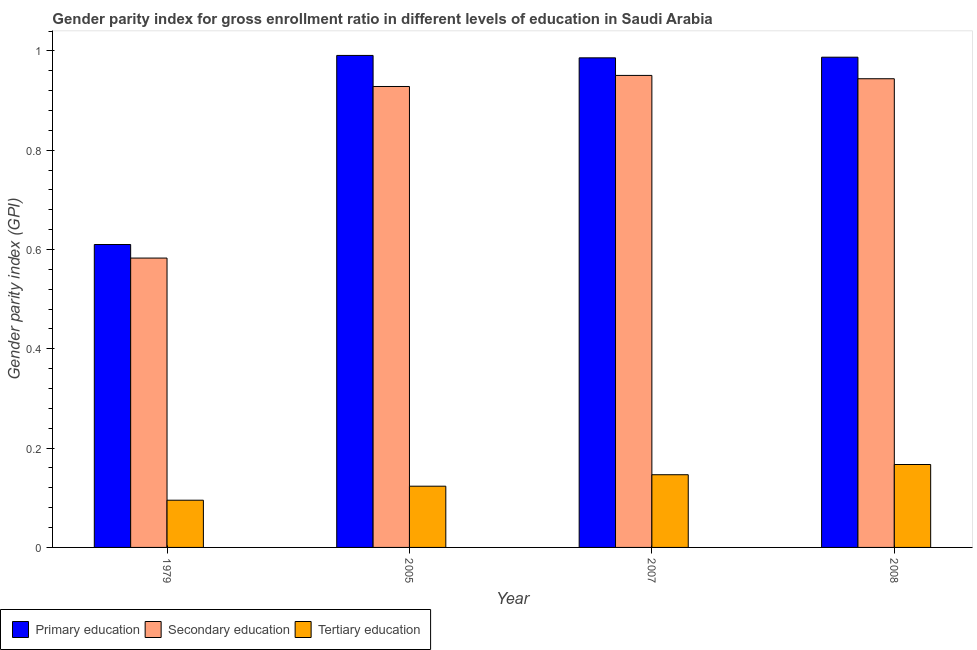How many groups of bars are there?
Ensure brevity in your answer.  4. Are the number of bars per tick equal to the number of legend labels?
Offer a terse response. Yes. Are the number of bars on each tick of the X-axis equal?
Your answer should be compact. Yes. How many bars are there on the 1st tick from the right?
Your response must be concise. 3. What is the label of the 4th group of bars from the left?
Ensure brevity in your answer.  2008. What is the gender parity index in primary education in 2005?
Ensure brevity in your answer.  0.99. Across all years, what is the maximum gender parity index in primary education?
Offer a terse response. 0.99. Across all years, what is the minimum gender parity index in secondary education?
Your response must be concise. 0.58. In which year was the gender parity index in primary education maximum?
Provide a short and direct response. 2005. In which year was the gender parity index in tertiary education minimum?
Your response must be concise. 1979. What is the total gender parity index in secondary education in the graph?
Offer a very short reply. 3.41. What is the difference between the gender parity index in primary education in 2007 and that in 2008?
Your answer should be compact. -0. What is the difference between the gender parity index in primary education in 2008 and the gender parity index in tertiary education in 2005?
Keep it short and to the point. -0. What is the average gender parity index in secondary education per year?
Keep it short and to the point. 0.85. In the year 2005, what is the difference between the gender parity index in secondary education and gender parity index in tertiary education?
Your answer should be compact. 0. What is the ratio of the gender parity index in secondary education in 1979 to that in 2008?
Provide a succinct answer. 0.62. Is the difference between the gender parity index in secondary education in 2005 and 2007 greater than the difference between the gender parity index in tertiary education in 2005 and 2007?
Make the answer very short. No. What is the difference between the highest and the second highest gender parity index in primary education?
Your response must be concise. 0. What is the difference between the highest and the lowest gender parity index in secondary education?
Provide a succinct answer. 0.37. In how many years, is the gender parity index in secondary education greater than the average gender parity index in secondary education taken over all years?
Give a very brief answer. 3. What does the 3rd bar from the left in 2007 represents?
Give a very brief answer. Tertiary education. What does the 1st bar from the right in 1979 represents?
Your answer should be compact. Tertiary education. Is it the case that in every year, the sum of the gender parity index in primary education and gender parity index in secondary education is greater than the gender parity index in tertiary education?
Your response must be concise. Yes. How many years are there in the graph?
Keep it short and to the point. 4. Are the values on the major ticks of Y-axis written in scientific E-notation?
Keep it short and to the point. No. Does the graph contain grids?
Your answer should be very brief. No. What is the title of the graph?
Your response must be concise. Gender parity index for gross enrollment ratio in different levels of education in Saudi Arabia. Does "ICT services" appear as one of the legend labels in the graph?
Give a very brief answer. No. What is the label or title of the X-axis?
Provide a short and direct response. Year. What is the label or title of the Y-axis?
Provide a short and direct response. Gender parity index (GPI). What is the Gender parity index (GPI) in Primary education in 1979?
Make the answer very short. 0.61. What is the Gender parity index (GPI) in Secondary education in 1979?
Provide a short and direct response. 0.58. What is the Gender parity index (GPI) in Tertiary education in 1979?
Provide a succinct answer. 0.1. What is the Gender parity index (GPI) of Primary education in 2005?
Make the answer very short. 0.99. What is the Gender parity index (GPI) of Secondary education in 2005?
Your answer should be compact. 0.93. What is the Gender parity index (GPI) of Tertiary education in 2005?
Keep it short and to the point. 0.12. What is the Gender parity index (GPI) of Primary education in 2007?
Give a very brief answer. 0.99. What is the Gender parity index (GPI) of Secondary education in 2007?
Your answer should be compact. 0.95. What is the Gender parity index (GPI) of Tertiary education in 2007?
Provide a short and direct response. 0.15. What is the Gender parity index (GPI) of Primary education in 2008?
Your answer should be very brief. 0.99. What is the Gender parity index (GPI) in Secondary education in 2008?
Your answer should be compact. 0.94. What is the Gender parity index (GPI) of Tertiary education in 2008?
Your answer should be very brief. 0.17. Across all years, what is the maximum Gender parity index (GPI) of Primary education?
Give a very brief answer. 0.99. Across all years, what is the maximum Gender parity index (GPI) in Secondary education?
Provide a succinct answer. 0.95. Across all years, what is the maximum Gender parity index (GPI) of Tertiary education?
Offer a very short reply. 0.17. Across all years, what is the minimum Gender parity index (GPI) of Primary education?
Your response must be concise. 0.61. Across all years, what is the minimum Gender parity index (GPI) of Secondary education?
Ensure brevity in your answer.  0.58. Across all years, what is the minimum Gender parity index (GPI) in Tertiary education?
Your answer should be very brief. 0.1. What is the total Gender parity index (GPI) in Primary education in the graph?
Your answer should be very brief. 3.57. What is the total Gender parity index (GPI) of Secondary education in the graph?
Ensure brevity in your answer.  3.41. What is the total Gender parity index (GPI) of Tertiary education in the graph?
Provide a succinct answer. 0.53. What is the difference between the Gender parity index (GPI) of Primary education in 1979 and that in 2005?
Offer a terse response. -0.38. What is the difference between the Gender parity index (GPI) of Secondary education in 1979 and that in 2005?
Keep it short and to the point. -0.35. What is the difference between the Gender parity index (GPI) in Tertiary education in 1979 and that in 2005?
Provide a succinct answer. -0.03. What is the difference between the Gender parity index (GPI) of Primary education in 1979 and that in 2007?
Your response must be concise. -0.38. What is the difference between the Gender parity index (GPI) of Secondary education in 1979 and that in 2007?
Your answer should be compact. -0.37. What is the difference between the Gender parity index (GPI) of Tertiary education in 1979 and that in 2007?
Offer a very short reply. -0.05. What is the difference between the Gender parity index (GPI) in Primary education in 1979 and that in 2008?
Your answer should be compact. -0.38. What is the difference between the Gender parity index (GPI) of Secondary education in 1979 and that in 2008?
Give a very brief answer. -0.36. What is the difference between the Gender parity index (GPI) of Tertiary education in 1979 and that in 2008?
Ensure brevity in your answer.  -0.07. What is the difference between the Gender parity index (GPI) in Primary education in 2005 and that in 2007?
Give a very brief answer. 0. What is the difference between the Gender parity index (GPI) in Secondary education in 2005 and that in 2007?
Keep it short and to the point. -0.02. What is the difference between the Gender parity index (GPI) in Tertiary education in 2005 and that in 2007?
Keep it short and to the point. -0.02. What is the difference between the Gender parity index (GPI) in Primary education in 2005 and that in 2008?
Keep it short and to the point. 0. What is the difference between the Gender parity index (GPI) in Secondary education in 2005 and that in 2008?
Offer a terse response. -0.02. What is the difference between the Gender parity index (GPI) in Tertiary education in 2005 and that in 2008?
Keep it short and to the point. -0.04. What is the difference between the Gender parity index (GPI) of Primary education in 2007 and that in 2008?
Provide a short and direct response. -0. What is the difference between the Gender parity index (GPI) of Secondary education in 2007 and that in 2008?
Offer a terse response. 0.01. What is the difference between the Gender parity index (GPI) in Tertiary education in 2007 and that in 2008?
Your response must be concise. -0.02. What is the difference between the Gender parity index (GPI) of Primary education in 1979 and the Gender parity index (GPI) of Secondary education in 2005?
Your response must be concise. -0.32. What is the difference between the Gender parity index (GPI) of Primary education in 1979 and the Gender parity index (GPI) of Tertiary education in 2005?
Keep it short and to the point. 0.49. What is the difference between the Gender parity index (GPI) in Secondary education in 1979 and the Gender parity index (GPI) in Tertiary education in 2005?
Offer a very short reply. 0.46. What is the difference between the Gender parity index (GPI) of Primary education in 1979 and the Gender parity index (GPI) of Secondary education in 2007?
Your answer should be very brief. -0.34. What is the difference between the Gender parity index (GPI) of Primary education in 1979 and the Gender parity index (GPI) of Tertiary education in 2007?
Offer a terse response. 0.46. What is the difference between the Gender parity index (GPI) in Secondary education in 1979 and the Gender parity index (GPI) in Tertiary education in 2007?
Keep it short and to the point. 0.44. What is the difference between the Gender parity index (GPI) in Primary education in 1979 and the Gender parity index (GPI) in Secondary education in 2008?
Provide a succinct answer. -0.33. What is the difference between the Gender parity index (GPI) in Primary education in 1979 and the Gender parity index (GPI) in Tertiary education in 2008?
Provide a succinct answer. 0.44. What is the difference between the Gender parity index (GPI) of Secondary education in 1979 and the Gender parity index (GPI) of Tertiary education in 2008?
Provide a short and direct response. 0.42. What is the difference between the Gender parity index (GPI) of Primary education in 2005 and the Gender parity index (GPI) of Secondary education in 2007?
Ensure brevity in your answer.  0.04. What is the difference between the Gender parity index (GPI) of Primary education in 2005 and the Gender parity index (GPI) of Tertiary education in 2007?
Offer a very short reply. 0.84. What is the difference between the Gender parity index (GPI) of Secondary education in 2005 and the Gender parity index (GPI) of Tertiary education in 2007?
Your answer should be very brief. 0.78. What is the difference between the Gender parity index (GPI) of Primary education in 2005 and the Gender parity index (GPI) of Secondary education in 2008?
Your answer should be very brief. 0.05. What is the difference between the Gender parity index (GPI) in Primary education in 2005 and the Gender parity index (GPI) in Tertiary education in 2008?
Make the answer very short. 0.82. What is the difference between the Gender parity index (GPI) of Secondary education in 2005 and the Gender parity index (GPI) of Tertiary education in 2008?
Your answer should be compact. 0.76. What is the difference between the Gender parity index (GPI) of Primary education in 2007 and the Gender parity index (GPI) of Secondary education in 2008?
Provide a succinct answer. 0.04. What is the difference between the Gender parity index (GPI) of Primary education in 2007 and the Gender parity index (GPI) of Tertiary education in 2008?
Your answer should be compact. 0.82. What is the difference between the Gender parity index (GPI) in Secondary education in 2007 and the Gender parity index (GPI) in Tertiary education in 2008?
Offer a terse response. 0.78. What is the average Gender parity index (GPI) of Primary education per year?
Give a very brief answer. 0.89. What is the average Gender parity index (GPI) in Secondary education per year?
Your answer should be very brief. 0.85. What is the average Gender parity index (GPI) in Tertiary education per year?
Make the answer very short. 0.13. In the year 1979, what is the difference between the Gender parity index (GPI) in Primary education and Gender parity index (GPI) in Secondary education?
Give a very brief answer. 0.03. In the year 1979, what is the difference between the Gender parity index (GPI) in Primary education and Gender parity index (GPI) in Tertiary education?
Offer a terse response. 0.52. In the year 1979, what is the difference between the Gender parity index (GPI) in Secondary education and Gender parity index (GPI) in Tertiary education?
Keep it short and to the point. 0.49. In the year 2005, what is the difference between the Gender parity index (GPI) in Primary education and Gender parity index (GPI) in Secondary education?
Make the answer very short. 0.06. In the year 2005, what is the difference between the Gender parity index (GPI) of Primary education and Gender parity index (GPI) of Tertiary education?
Provide a succinct answer. 0.87. In the year 2005, what is the difference between the Gender parity index (GPI) of Secondary education and Gender parity index (GPI) of Tertiary education?
Offer a very short reply. 0.81. In the year 2007, what is the difference between the Gender parity index (GPI) of Primary education and Gender parity index (GPI) of Secondary education?
Keep it short and to the point. 0.04. In the year 2007, what is the difference between the Gender parity index (GPI) of Primary education and Gender parity index (GPI) of Tertiary education?
Keep it short and to the point. 0.84. In the year 2007, what is the difference between the Gender parity index (GPI) in Secondary education and Gender parity index (GPI) in Tertiary education?
Offer a very short reply. 0.8. In the year 2008, what is the difference between the Gender parity index (GPI) in Primary education and Gender parity index (GPI) in Secondary education?
Make the answer very short. 0.04. In the year 2008, what is the difference between the Gender parity index (GPI) in Primary education and Gender parity index (GPI) in Tertiary education?
Your response must be concise. 0.82. In the year 2008, what is the difference between the Gender parity index (GPI) in Secondary education and Gender parity index (GPI) in Tertiary education?
Offer a very short reply. 0.78. What is the ratio of the Gender parity index (GPI) of Primary education in 1979 to that in 2005?
Keep it short and to the point. 0.62. What is the ratio of the Gender parity index (GPI) of Secondary education in 1979 to that in 2005?
Give a very brief answer. 0.63. What is the ratio of the Gender parity index (GPI) in Tertiary education in 1979 to that in 2005?
Your answer should be very brief. 0.77. What is the ratio of the Gender parity index (GPI) of Primary education in 1979 to that in 2007?
Your response must be concise. 0.62. What is the ratio of the Gender parity index (GPI) in Secondary education in 1979 to that in 2007?
Offer a very short reply. 0.61. What is the ratio of the Gender parity index (GPI) of Tertiary education in 1979 to that in 2007?
Give a very brief answer. 0.65. What is the ratio of the Gender parity index (GPI) of Primary education in 1979 to that in 2008?
Make the answer very short. 0.62. What is the ratio of the Gender parity index (GPI) in Secondary education in 1979 to that in 2008?
Offer a terse response. 0.62. What is the ratio of the Gender parity index (GPI) in Tertiary education in 1979 to that in 2008?
Provide a succinct answer. 0.57. What is the ratio of the Gender parity index (GPI) of Secondary education in 2005 to that in 2007?
Your answer should be very brief. 0.98. What is the ratio of the Gender parity index (GPI) in Tertiary education in 2005 to that in 2007?
Give a very brief answer. 0.84. What is the ratio of the Gender parity index (GPI) in Secondary education in 2005 to that in 2008?
Make the answer very short. 0.98. What is the ratio of the Gender parity index (GPI) of Tertiary education in 2005 to that in 2008?
Keep it short and to the point. 0.74. What is the ratio of the Gender parity index (GPI) of Secondary education in 2007 to that in 2008?
Offer a very short reply. 1.01. What is the ratio of the Gender parity index (GPI) of Tertiary education in 2007 to that in 2008?
Give a very brief answer. 0.88. What is the difference between the highest and the second highest Gender parity index (GPI) of Primary education?
Make the answer very short. 0. What is the difference between the highest and the second highest Gender parity index (GPI) of Secondary education?
Your answer should be very brief. 0.01. What is the difference between the highest and the second highest Gender parity index (GPI) in Tertiary education?
Offer a very short reply. 0.02. What is the difference between the highest and the lowest Gender parity index (GPI) of Primary education?
Your answer should be very brief. 0.38. What is the difference between the highest and the lowest Gender parity index (GPI) in Secondary education?
Offer a terse response. 0.37. What is the difference between the highest and the lowest Gender parity index (GPI) in Tertiary education?
Provide a succinct answer. 0.07. 